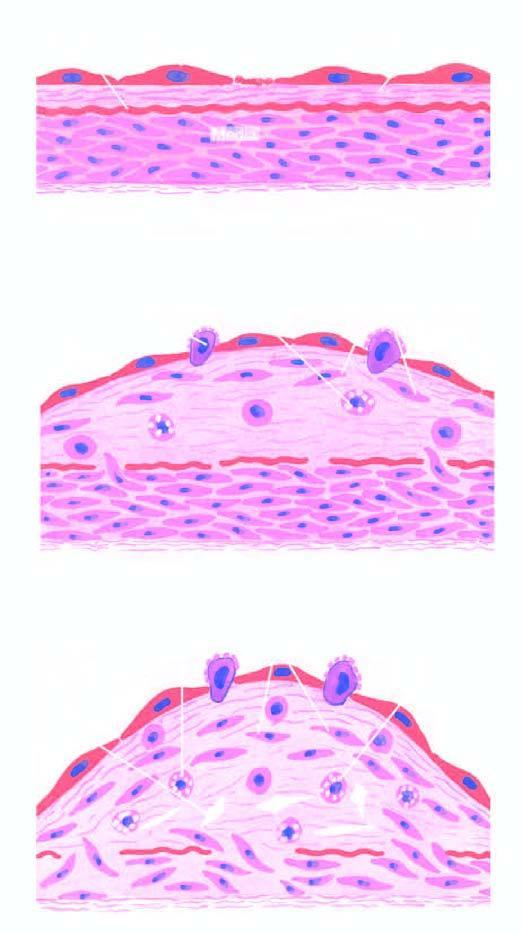how is diagrammatic representation of pathogenesis of atherosclerosis explained?
Answer the question using a single word or phrase. By 'reaction-to-injury 'hypothesis 